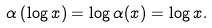<formula> <loc_0><loc_0><loc_500><loc_500>\alpha \left ( \log x \right ) = \log \alpha ( x ) = \log x .</formula> 